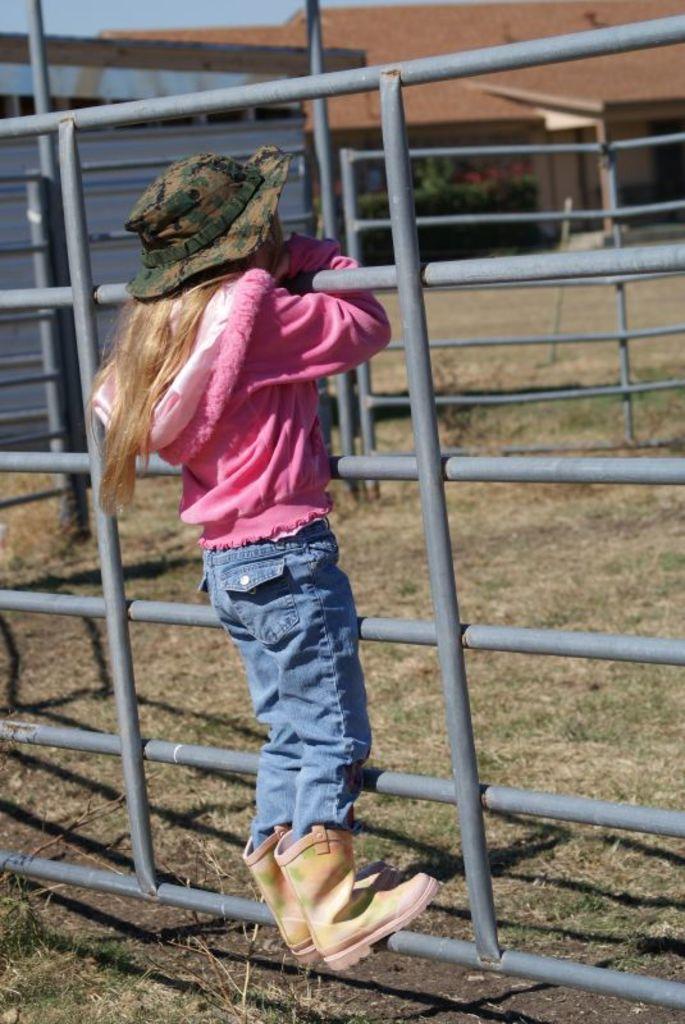Describe this image in one or two sentences. In the image there is a girl standing on a rod by holding the support of other rods and the ground below the girl's feet is covered with grass, in the background there is a house. 